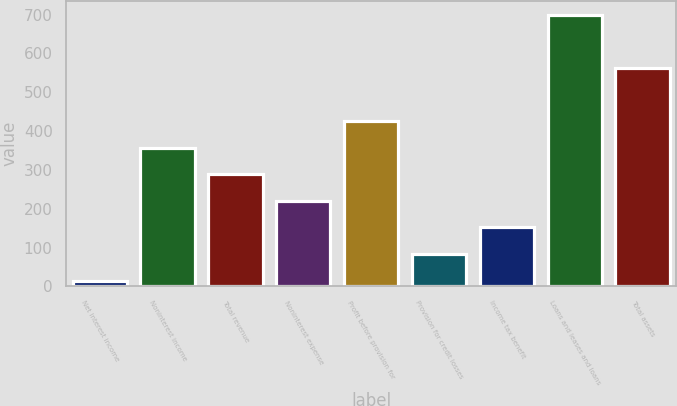Convert chart. <chart><loc_0><loc_0><loc_500><loc_500><bar_chart><fcel>Net interest income<fcel>Noninterest income<fcel>Total revenue<fcel>Noninterest expense<fcel>Profit before provision for<fcel>Provision for credit losses<fcel>Income tax benefit<fcel>Loans and leases and loans<fcel>Total assets<nl><fcel>15<fcel>357.5<fcel>289<fcel>220.5<fcel>426<fcel>83.5<fcel>152<fcel>700<fcel>563<nl></chart> 